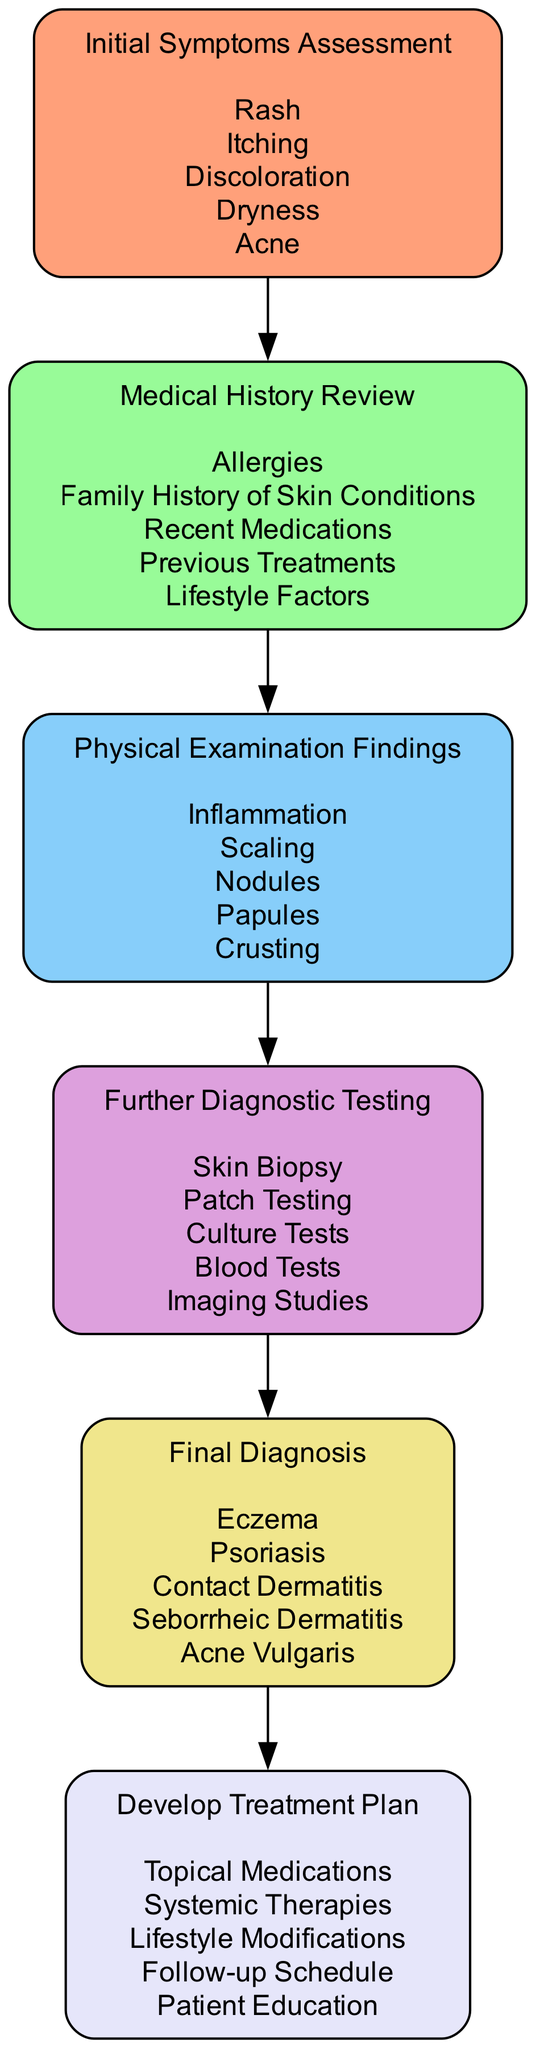What is the first step in the diagnostic workflow? The first node in the diagram, labeled "Initial Symptoms Assessment," indicates that it is the first step.
Answer: Initial Symptoms Assessment How many options are available in the "Medical History Review" step? The "Medical History Review" has five options listed under it: "Allergies," "Family History of Skin Conditions," "Recent Medications," "Previous Treatments," and "Lifestyle Factors." Counting these options gives a total of five.
Answer: 5 What connects "Physical Examination Findings" to "Final Diagnosis"? The connection is established through the sequential nature of the diagram; "Physical Examination Findings" is directly linked to "Final Diagnosis" by the diagnostic workflow outlined in the steps, indicating the process flows from examination to diagnosis.
Answer: Physical Examination Findings Which condition is diagnosed after the "Further Diagnostic Testing"? The flow indicates that after "Further Diagnostic Testing," it leads to the "Final Diagnosis" step, which includes several options. One of the conditions listed is "Contact Dermatitis."
Answer: Contact Dermatitis What is the last step in the skin condition diagnosis workflow? The last node in the diagram is labeled "Develop Treatment Plan," showing where the workflow ends after reaching a diagnosis.
Answer: Develop Treatment Plan How many diagnostic steps are present in the workflow? Counting the nodes in the diagram, five diagnostic steps are identified: "Initial Symptoms Assessment," "Medical History Review," "Physical Examination Findings," "Further Diagnostic Testing," and "Final Diagnosis." Thus, there are five steps in total.
Answer: 5 Which option is included under "Develop Treatment Plan"? The "Develop Treatment Plan" node includes multiple options listed, one of which is "Topical Medications," which is directly stated in the options section of that node.
Answer: Topical Medications What is the immediate next step after "Physical Examination Findings"? According to the diagram's flow, "Physical Examination Findings" directly leads to "Further Diagnostic Testing," indicating that this is the next step in the workflow.
Answer: Further Diagnostic Testing 